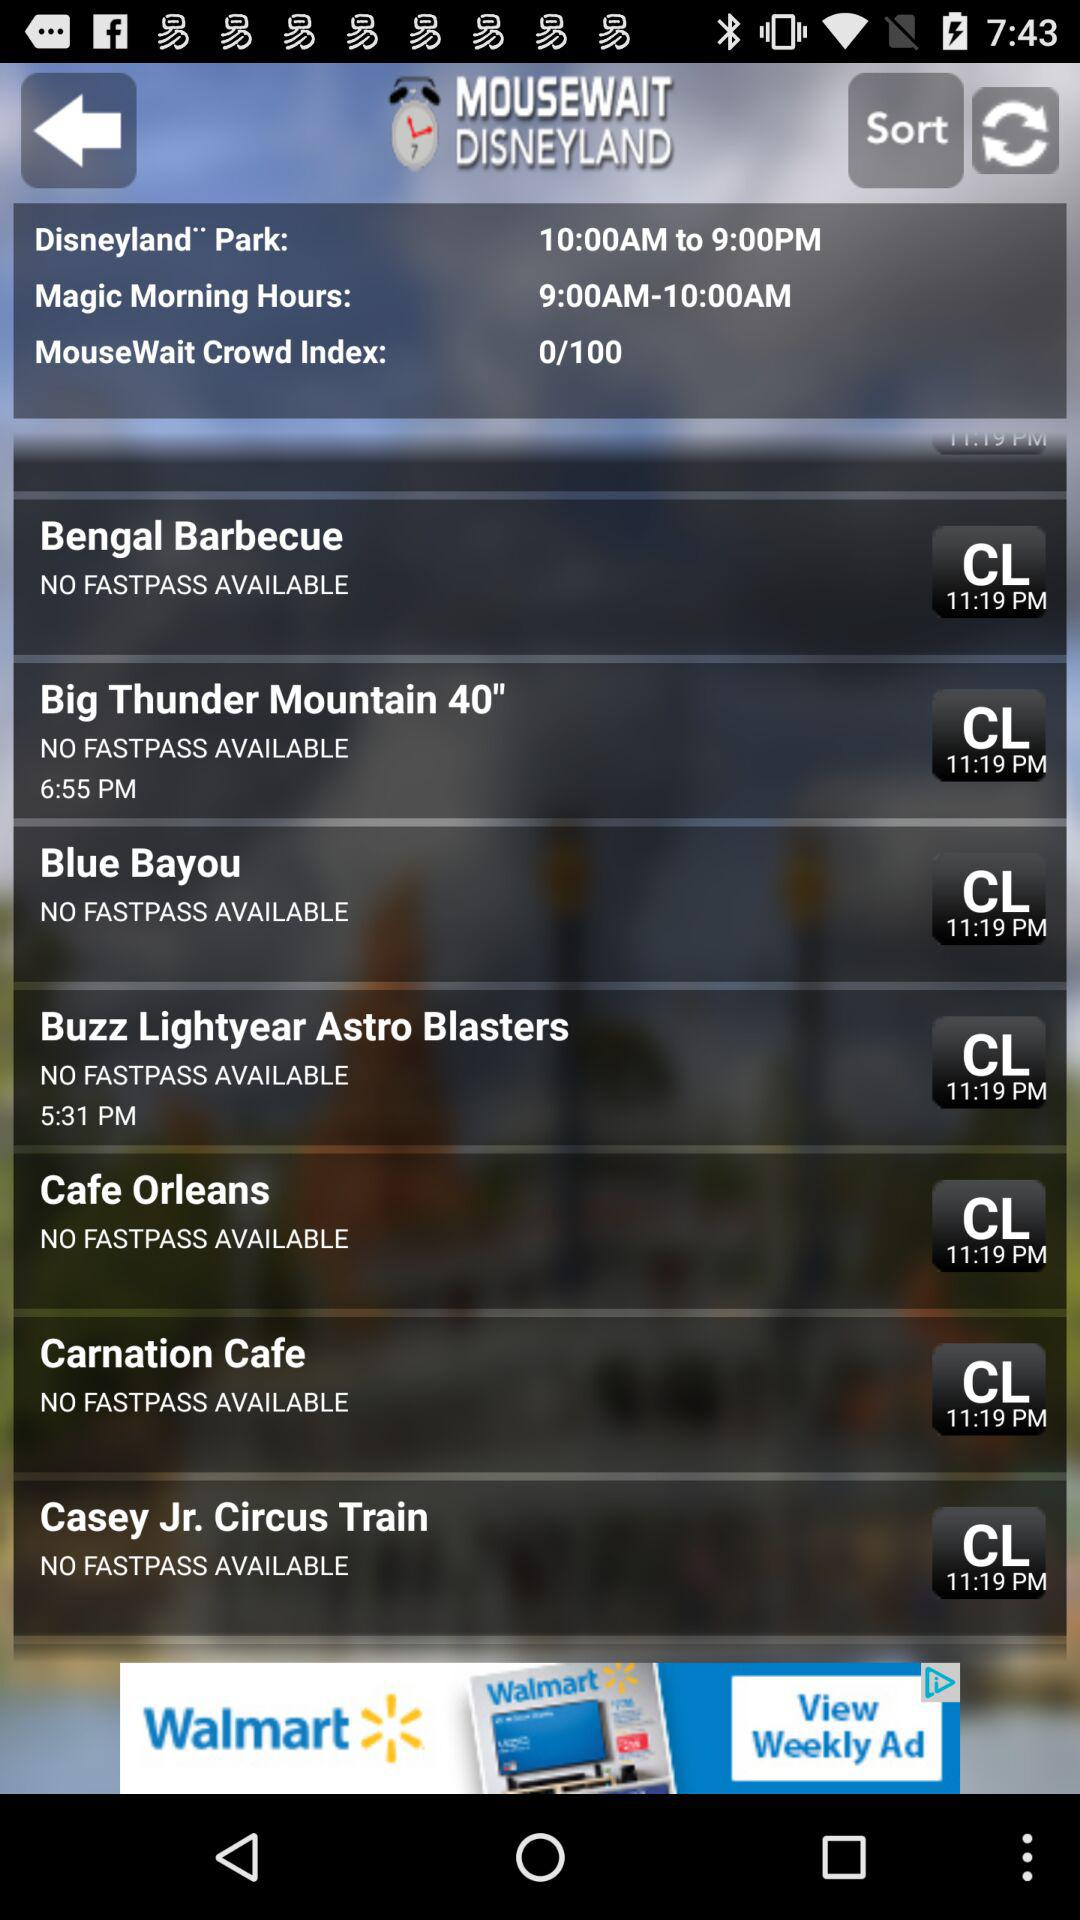What's the opening time of the Disneyland park? The opening time of the Disneyland park is 10:00 AM. 